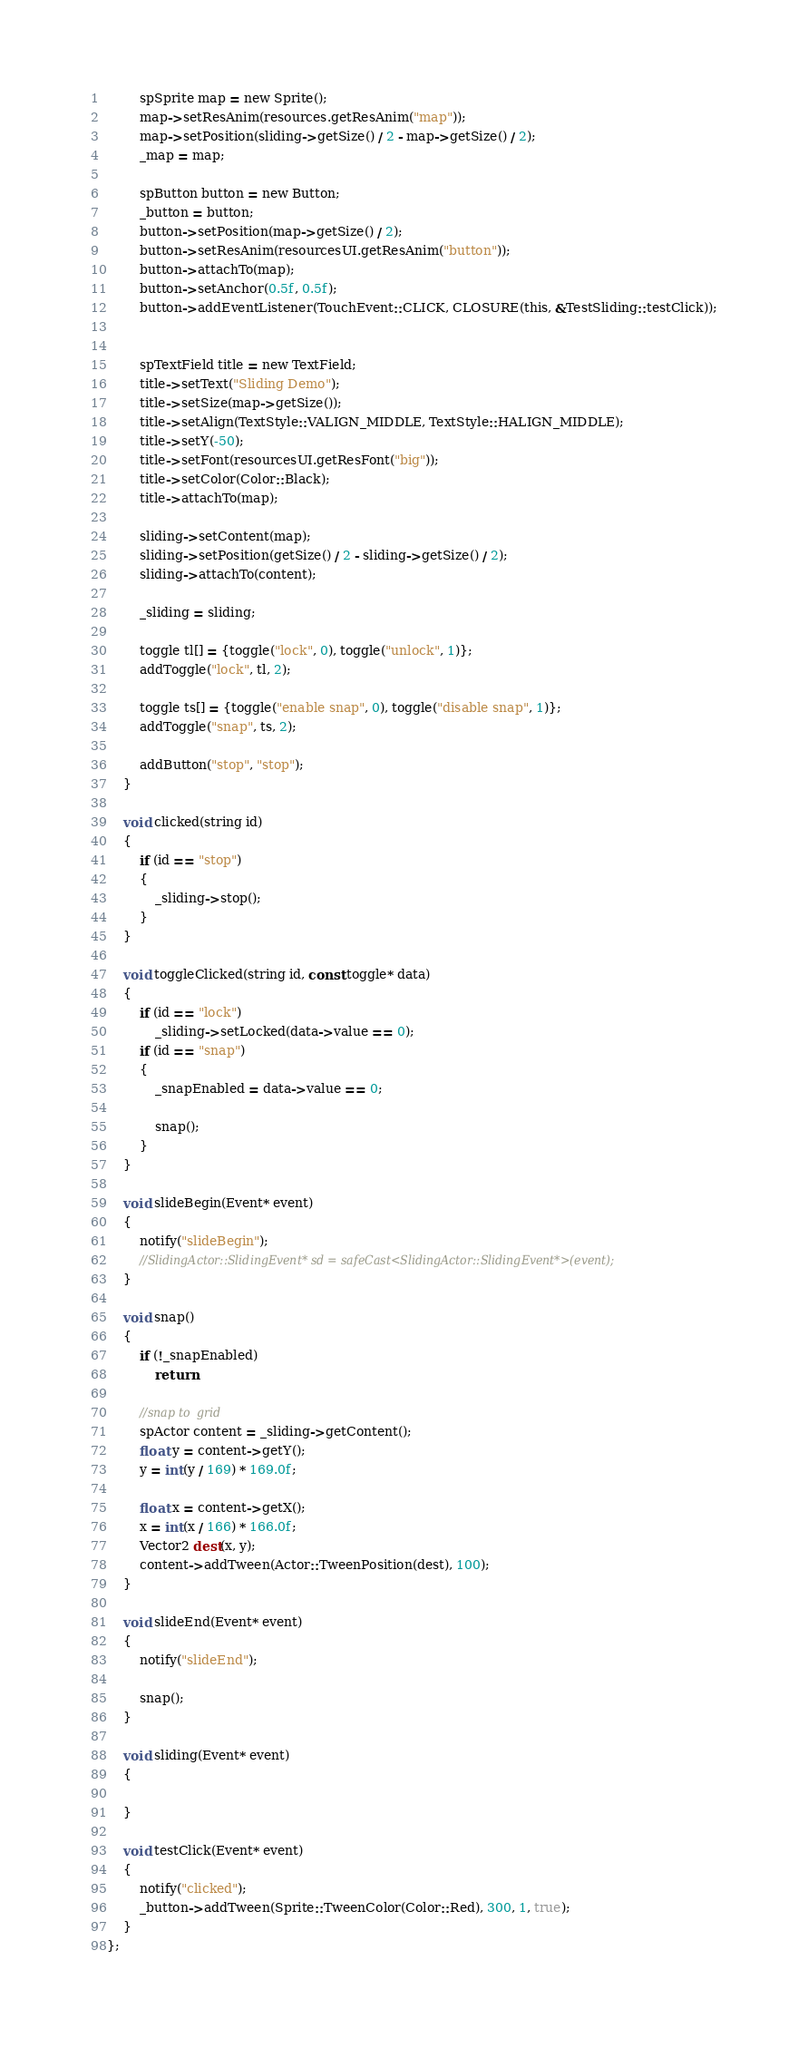<code> <loc_0><loc_0><loc_500><loc_500><_C_>
        spSprite map = new Sprite();
        map->setResAnim(resources.getResAnim("map"));
        map->setPosition(sliding->getSize() / 2 - map->getSize() / 2);
        _map = map;

        spButton button = new Button;
        _button = button;
        button->setPosition(map->getSize() / 2);
        button->setResAnim(resourcesUI.getResAnim("button"));
        button->attachTo(map);
        button->setAnchor(0.5f, 0.5f);
        button->addEventListener(TouchEvent::CLICK, CLOSURE(this, &TestSliding::testClick));


        spTextField title = new TextField;
        title->setText("Sliding Demo");
        title->setSize(map->getSize());
        title->setAlign(TextStyle::VALIGN_MIDDLE, TextStyle::HALIGN_MIDDLE);
        title->setY(-50);
        title->setFont(resourcesUI.getResFont("big"));
        title->setColor(Color::Black);
        title->attachTo(map);

        sliding->setContent(map);
        sliding->setPosition(getSize() / 2 - sliding->getSize() / 2);
        sliding->attachTo(content);

        _sliding = sliding;

        toggle tl[] = {toggle("lock", 0), toggle("unlock", 1)};
        addToggle("lock", tl, 2);

        toggle ts[] = {toggle("enable snap", 0), toggle("disable snap", 1)};
        addToggle("snap", ts, 2);

        addButton("stop", "stop");
    }

    void clicked(string id)
    {
        if (id == "stop")
        {
            _sliding->stop();
        }
    }

    void toggleClicked(string id, const toggle* data)
    {
        if (id == "lock")
            _sliding->setLocked(data->value == 0);
        if (id == "snap")
        {
            _snapEnabled = data->value == 0;

            snap();
        }
    }

    void slideBegin(Event* event)
    {
        notify("slideBegin");
        //SlidingActor::SlidingEvent* sd = safeCast<SlidingActor::SlidingEvent*>(event);
    }

    void snap()
    {
        if (!_snapEnabled)
            return;

        //snap to  grid
        spActor content = _sliding->getContent();
        float y = content->getY();
        y = int(y / 169) * 169.0f;

        float x = content->getX();
        x = int(x / 166) * 166.0f;
        Vector2 dest(x, y);
        content->addTween(Actor::TweenPosition(dest), 100);
    }

    void slideEnd(Event* event)
    {
        notify("slideEnd");

        snap();
    }

    void sliding(Event* event)
    {

    }

    void testClick(Event* event)
    {
        notify("clicked");
        _button->addTween(Sprite::TweenColor(Color::Red), 300, 1, true);
    }
};
</code> 